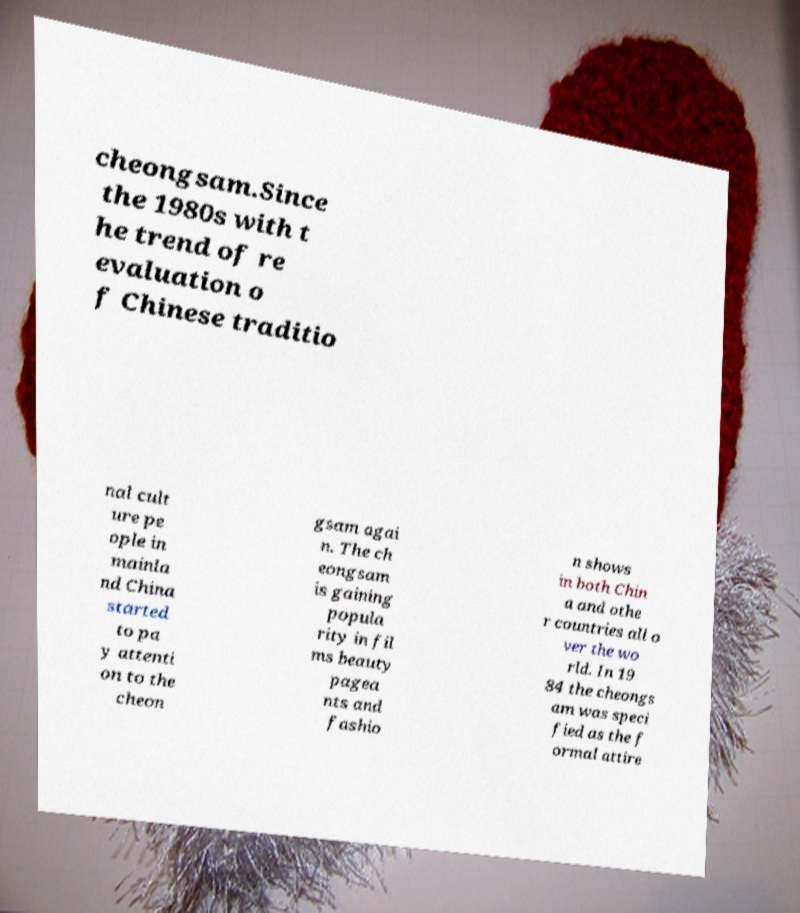Could you extract and type out the text from this image? cheongsam.Since the 1980s with t he trend of re evaluation o f Chinese traditio nal cult ure pe ople in mainla nd China started to pa y attenti on to the cheon gsam agai n. The ch eongsam is gaining popula rity in fil ms beauty pagea nts and fashio n shows in both Chin a and othe r countries all o ver the wo rld. In 19 84 the cheongs am was speci fied as the f ormal attire 